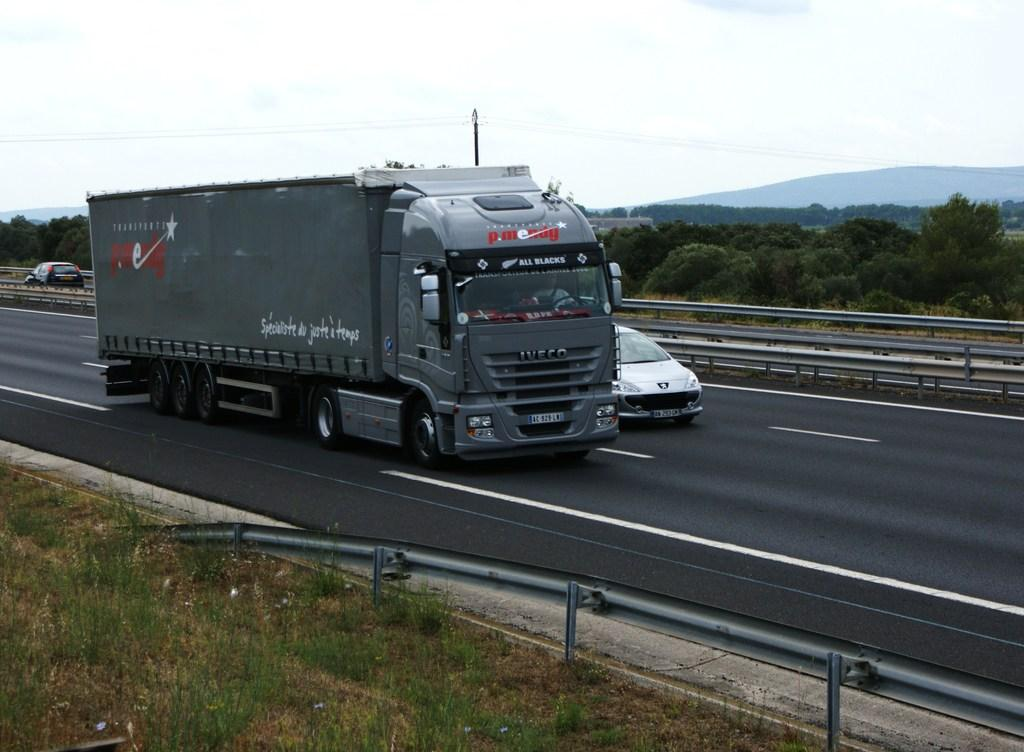What can be seen in the center of the image? There is a group of vehicles parked on the road in the center of the image. What is present in the background of the image? There are metal barriers, a group of trees, grass, a pole with cables, and the sky visible in the background. What type of vegetation is present in the background? There is a group of trees and grass present in the background. What is the purpose of the pole with cables in the background? The purpose of the pole with cables is not specified in the image, but it may be related to power or communication lines. Can you hear the wood laughing in the image? There is no wood or laughter present in the image; it is a still photograph. 